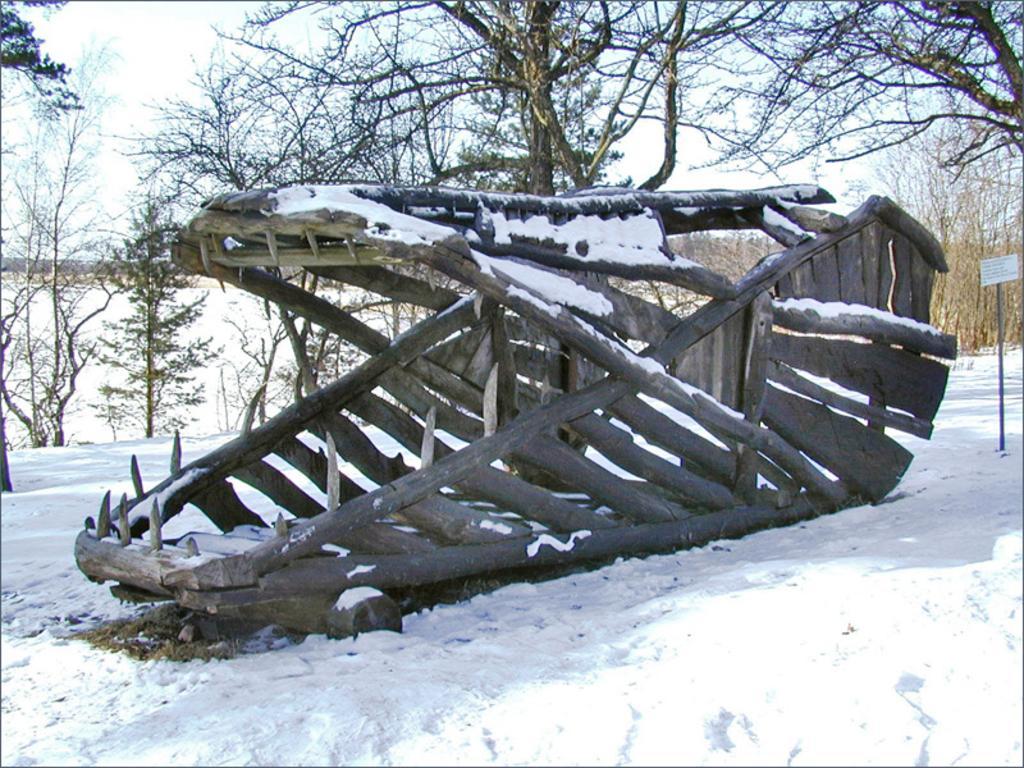Could you give a brief overview of what you see in this image? In this picture I can see the snow at the bottom, in the middle it looks like a wooden frame. In the background there are trees, at the top there is the sky. 